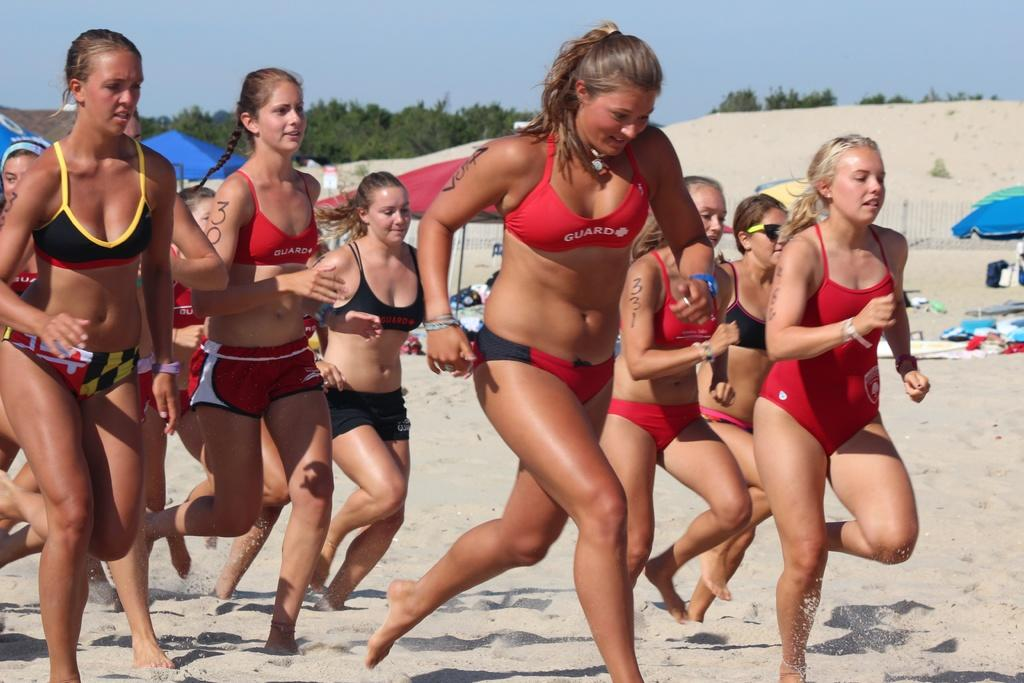<image>
Write a terse but informative summary of the picture. A girl with a bikini on that says Guard on it 